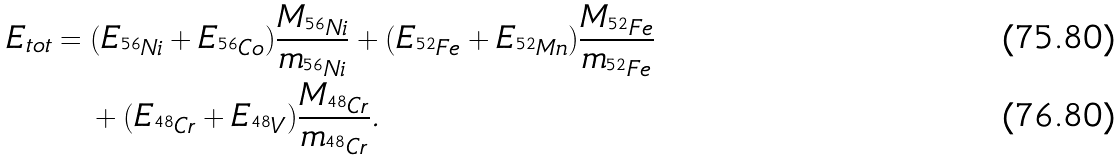<formula> <loc_0><loc_0><loc_500><loc_500>E _ { t o t } & = ( E _ { ^ { 5 6 } N i } + E _ { ^ { 5 6 } C o } ) \frac { M _ { ^ { 5 6 } N i } } { m _ { ^ { 5 6 } N i } } + ( E _ { ^ { 5 2 } F e } + E _ { ^ { 5 2 } M n } ) \frac { M _ { ^ { 5 2 } F e } } { m _ { ^ { 5 2 } F e } } \\ & \quad + ( E _ { ^ { 4 8 } C r } + E _ { ^ { 4 8 } V } ) \frac { M _ { ^ { 4 8 } C r } } { m _ { ^ { 4 8 } C r } } .</formula> 